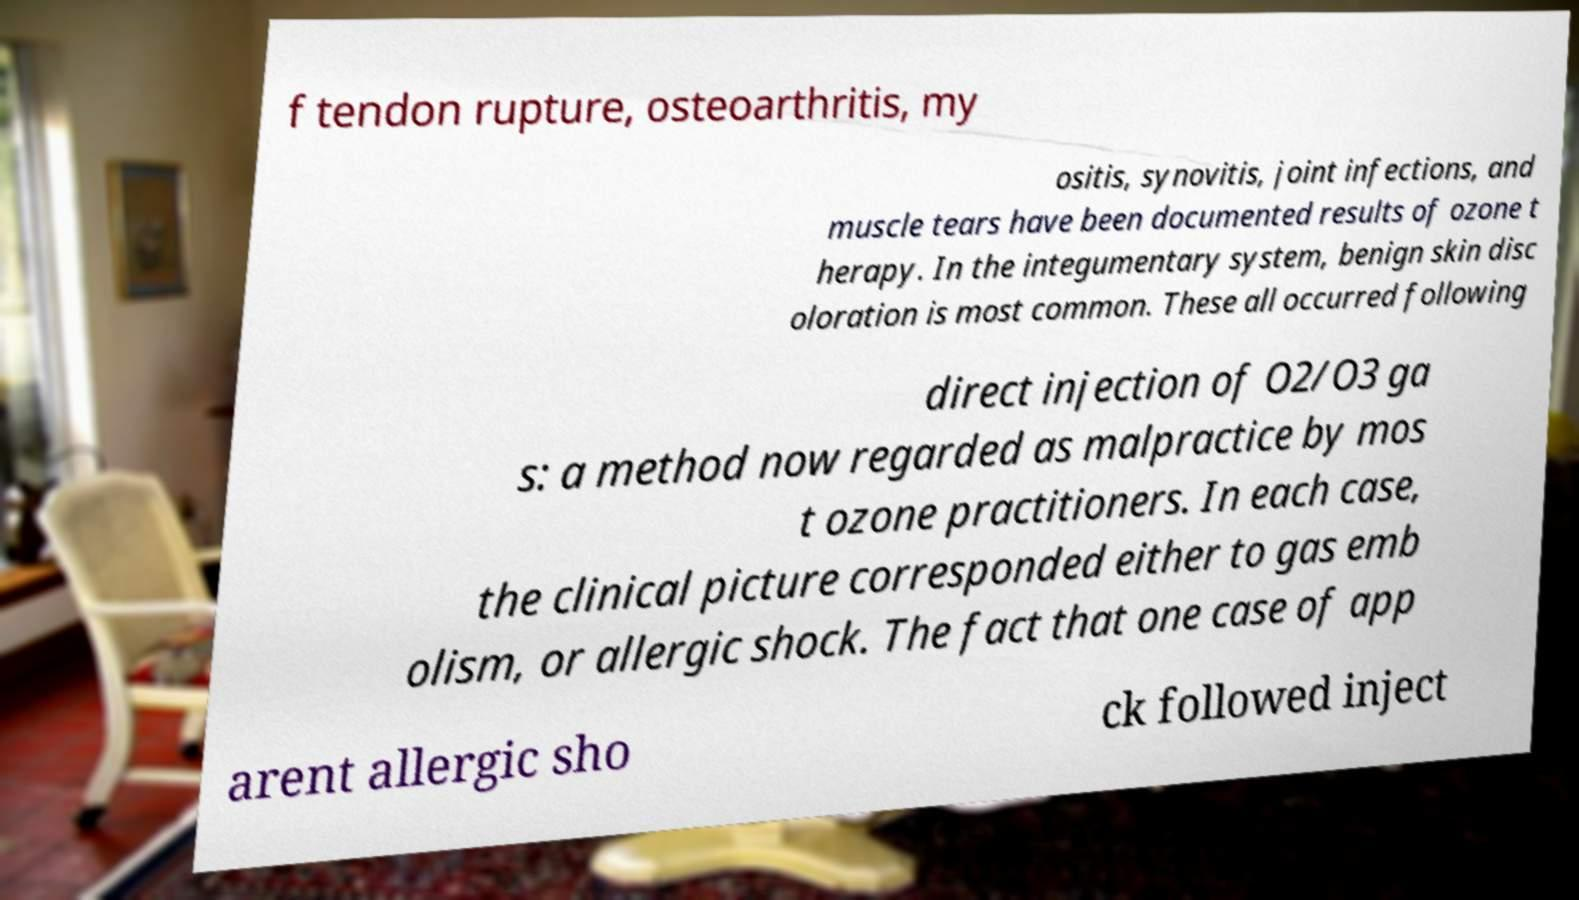Can you read and provide the text displayed in the image?This photo seems to have some interesting text. Can you extract and type it out for me? f tendon rupture, osteoarthritis, my ositis, synovitis, joint infections, and muscle tears have been documented results of ozone t herapy. In the integumentary system, benign skin disc oloration is most common. These all occurred following direct injection of O2/O3 ga s: a method now regarded as malpractice by mos t ozone practitioners. In each case, the clinical picture corresponded either to gas emb olism, or allergic shock. The fact that one case of app arent allergic sho ck followed inject 